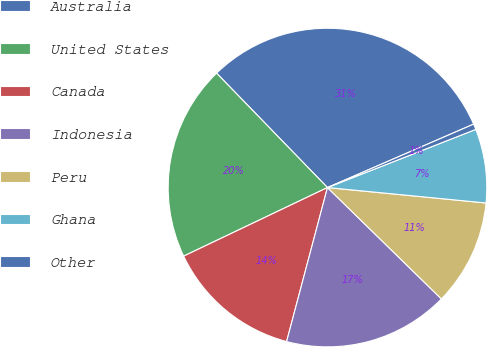Convert chart. <chart><loc_0><loc_0><loc_500><loc_500><pie_chart><fcel>Australia<fcel>United States<fcel>Canada<fcel>Indonesia<fcel>Peru<fcel>Ghana<fcel>Other<nl><fcel>30.74%<fcel>19.83%<fcel>13.79%<fcel>16.81%<fcel>10.78%<fcel>7.49%<fcel>0.57%<nl></chart> 